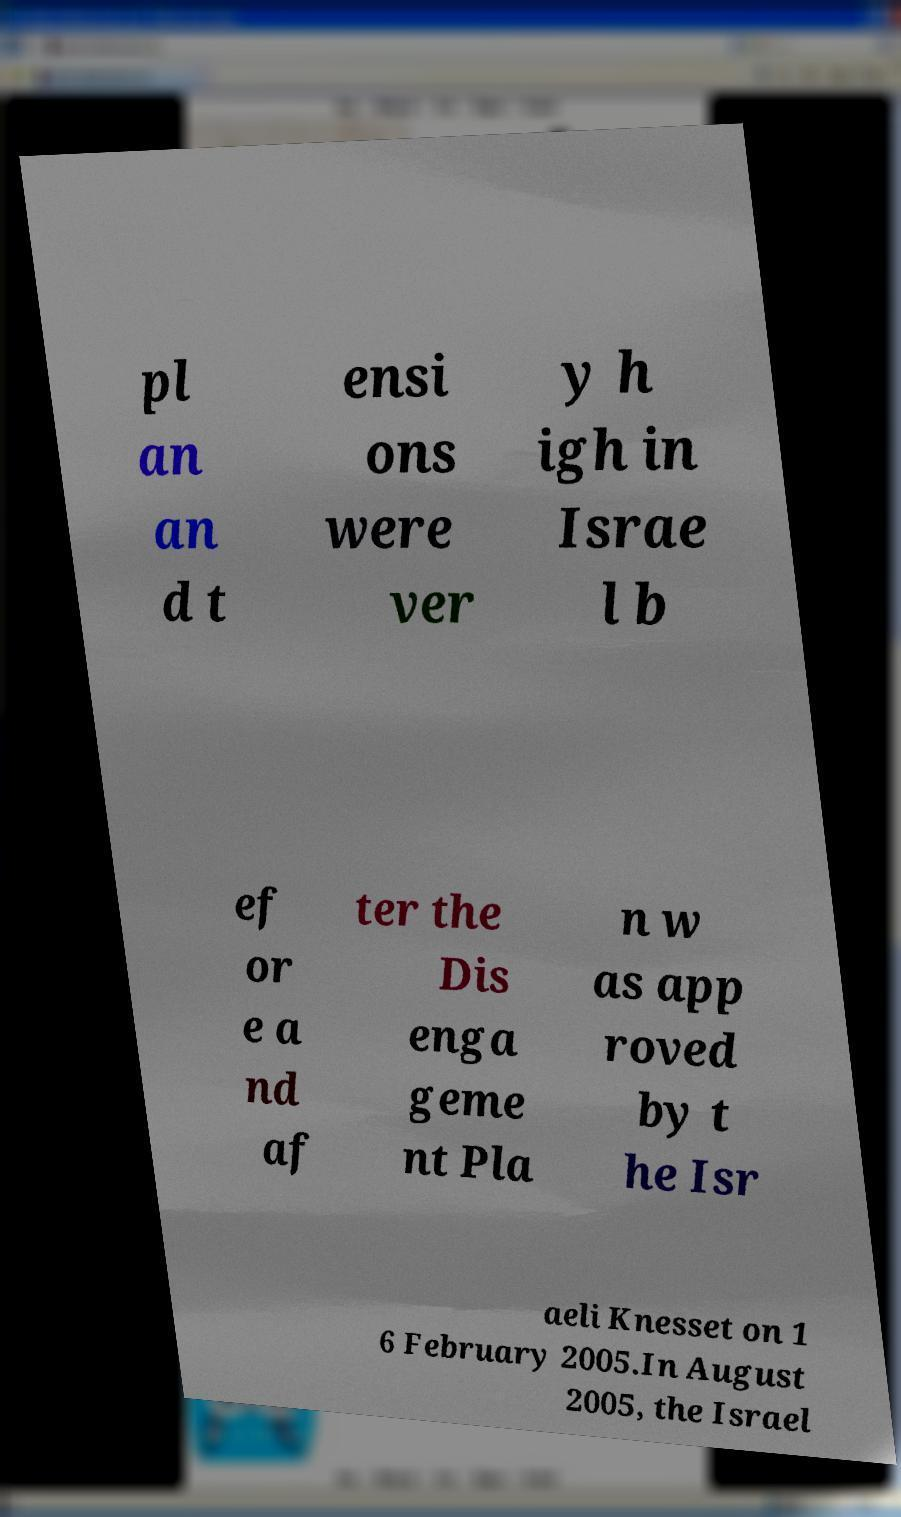Could you extract and type out the text from this image? pl an an d t ensi ons were ver y h igh in Israe l b ef or e a nd af ter the Dis enga geme nt Pla n w as app roved by t he Isr aeli Knesset on 1 6 February 2005.In August 2005, the Israel 